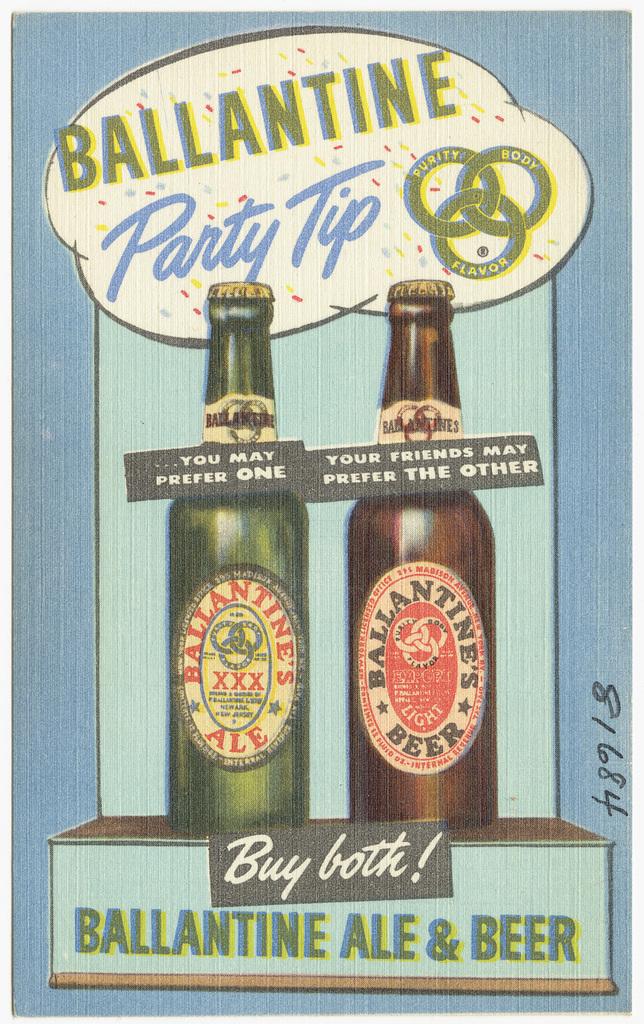Does ballantine still make drinks?
Ensure brevity in your answer.  Unanswerable. 